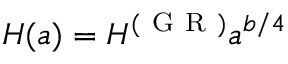<formula> <loc_0><loc_0><loc_500><loc_500>H ( a ) = H ^ { ( G R ) } a ^ { b / 4 }</formula> 